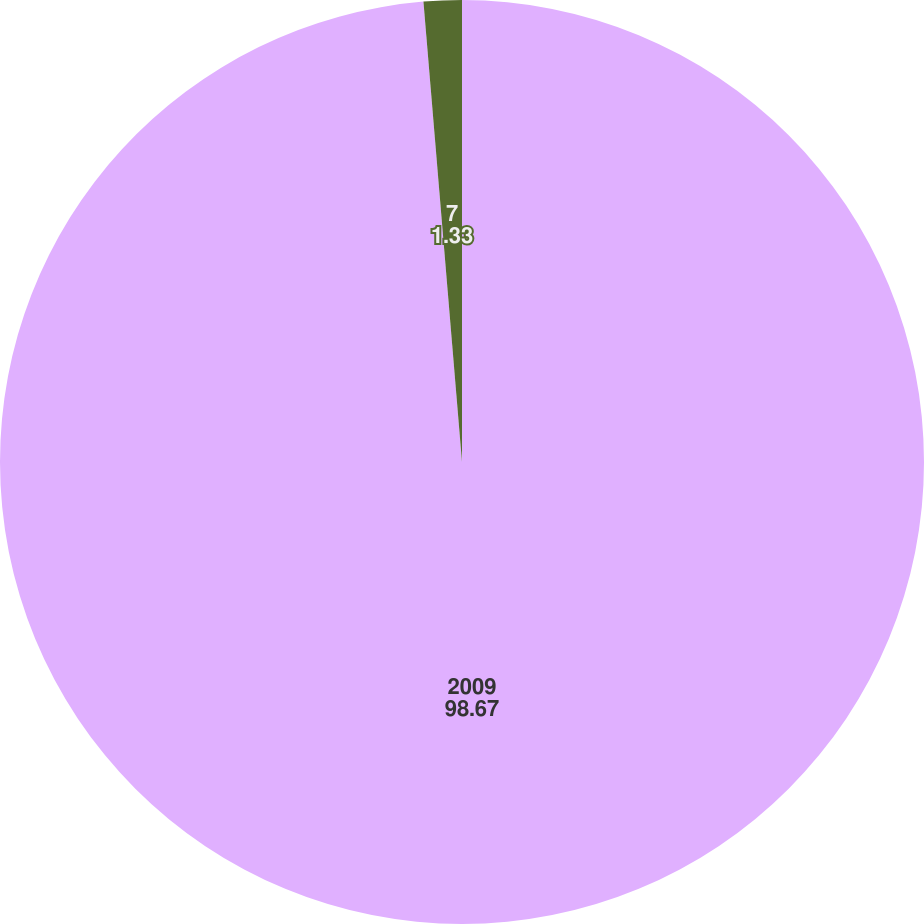Convert chart to OTSL. <chart><loc_0><loc_0><loc_500><loc_500><pie_chart><fcel>2009<fcel>7<nl><fcel>98.67%<fcel>1.33%<nl></chart> 